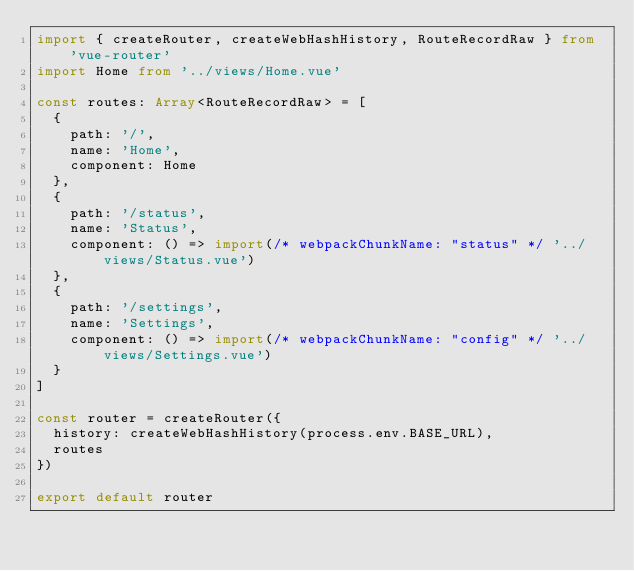<code> <loc_0><loc_0><loc_500><loc_500><_TypeScript_>import { createRouter, createWebHashHistory, RouteRecordRaw } from 'vue-router'
import Home from '../views/Home.vue'

const routes: Array<RouteRecordRaw> = [
  {
    path: '/',
    name: 'Home',
    component: Home
  },
  {
    path: '/status',
    name: 'Status',
    component: () => import(/* webpackChunkName: "status" */ '../views/Status.vue')
  },
  {
    path: '/settings',
    name: 'Settings',
    component: () => import(/* webpackChunkName: "config" */ '../views/Settings.vue')
  }
]

const router = createRouter({
  history: createWebHashHistory(process.env.BASE_URL),
  routes
})

export default router
</code> 